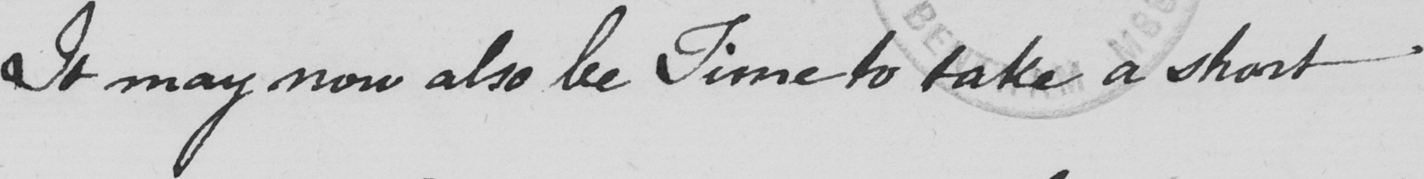Please transcribe the handwritten text in this image. It may now also be Time to take a short 